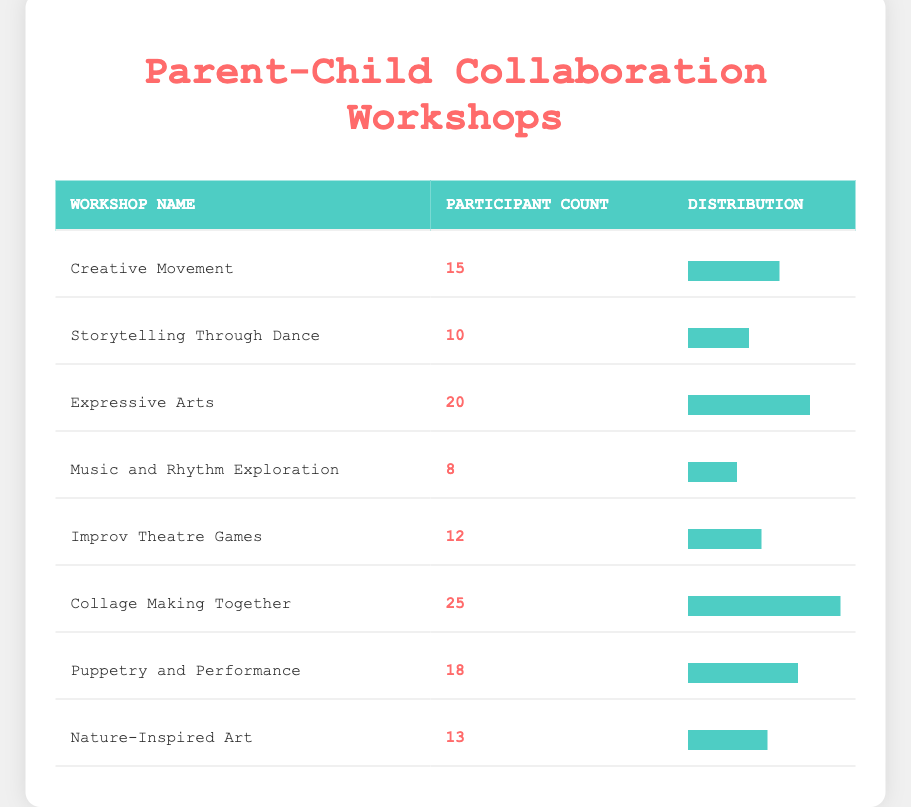What is the participant count for the workshop "Puppetry and Performance"? The table lists the participant count for each workshop in the second column. Looking for "Puppetry and Performance," I find the participant count is 18.
Answer: 18 Which workshop has the highest participant count? By reviewing the participant counts in the second column, I see that "Collage Making Together" has the highest count with 25 participants.
Answer: Collage Making Together How many more participants attended "Expressive Arts" compared to "Music and Rhythm Exploration"? The participant count for "Expressive Arts" is 20, and for "Music and Rhythm Exploration" it is 8. To find the difference, I subtract: 20 - 8 = 12.
Answer: 12 What is the total number of participants across all workshops? To find the total, I add all participant counts: (15 + 10 + 20 + 8 + 12 + 25 + 18 + 13) = 131.
Answer: 131 Did "Storytelling Through Dance" have more participants than "Improv Theatre Games"? "Storytelling Through Dance" has 10 participants and "Improv Theatre Games" has 12 participants. Since 10 is less than 12, the answer is no.
Answer: No What is the average number of participants per workshop? There are 8 workshops, and the total participant count is 131. To find the average, I divide the total by the number of workshops: 131 / 8 = 16.375.
Answer: 16.375 Which workshop has a participant count that is less than the average? The average participant count is 16.375. The workshops with participant counts less than this value are "Music and Rhythm Exploration" (8) and "Storytelling Through Dance" (10).
Answer: Music and Rhythm Exploration, Storytelling Through Dance How many workshops have more than 15 participants? I check the participant counts and find that "Expressive Arts," "Collage Making Together," "Puppetry and Performance," and "Creative Movement" have more than 15 participants. This results in a total of 4 workshops.
Answer: 4 Is there a workshop with exactly 12 participants? Checking the participant counts, I see that "Improv Theatre Games" has exactly 12 participants.
Answer: Yes 